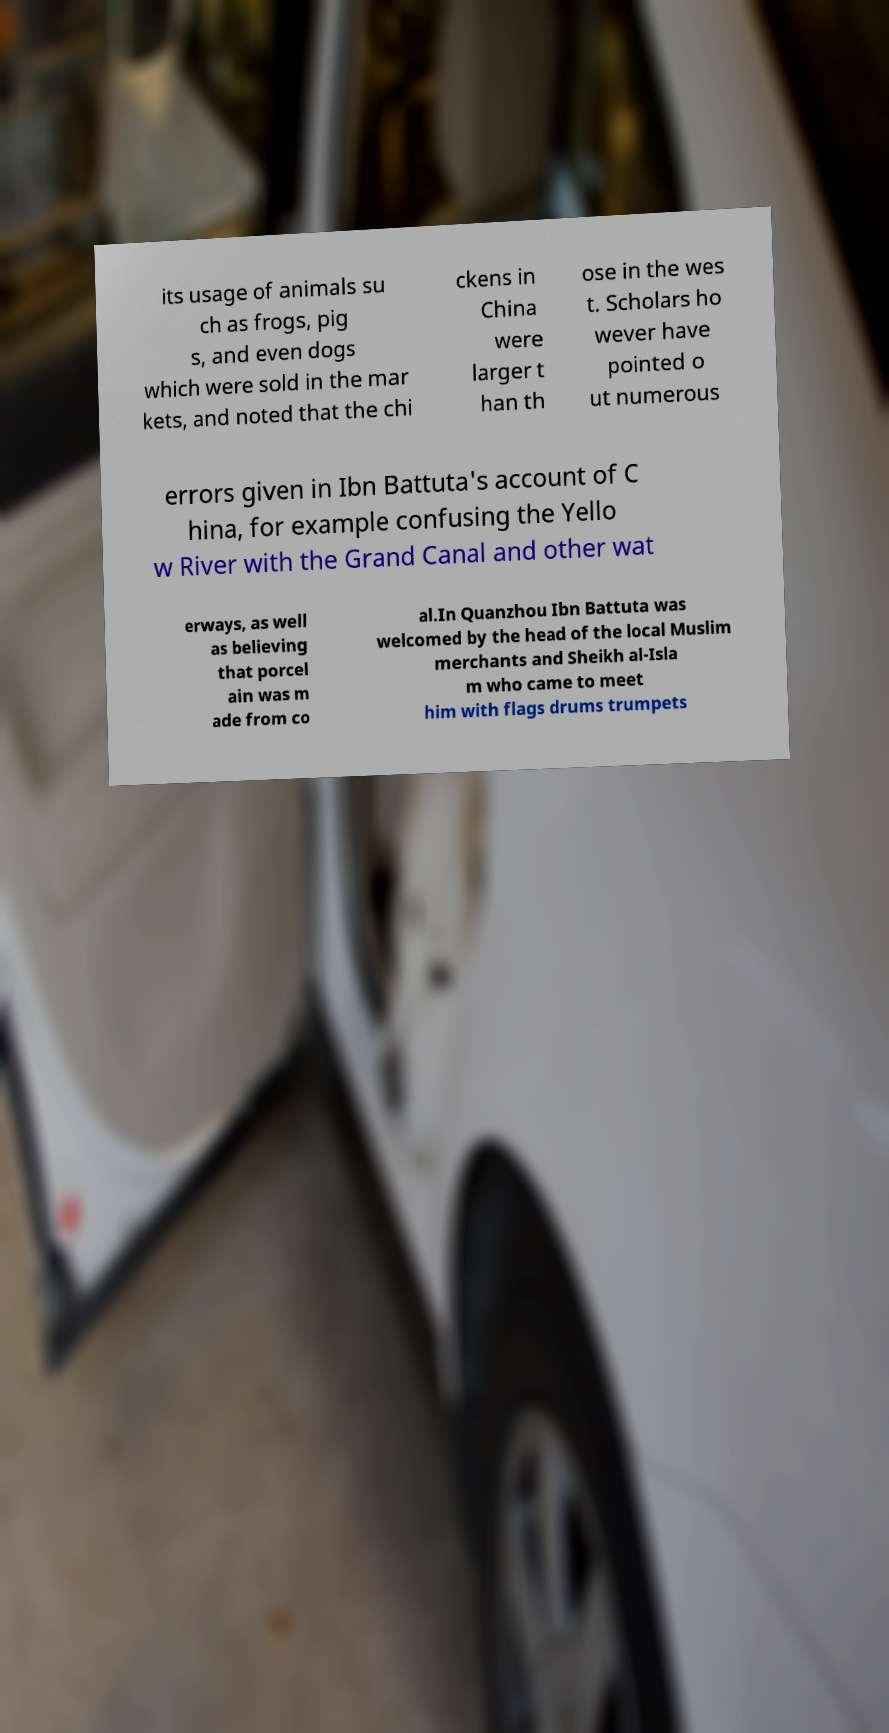Can you accurately transcribe the text from the provided image for me? its usage of animals su ch as frogs, pig s, and even dogs which were sold in the mar kets, and noted that the chi ckens in China were larger t han th ose in the wes t. Scholars ho wever have pointed o ut numerous errors given in Ibn Battuta's account of C hina, for example confusing the Yello w River with the Grand Canal and other wat erways, as well as believing that porcel ain was m ade from co al.In Quanzhou Ibn Battuta was welcomed by the head of the local Muslim merchants and Sheikh al-Isla m who came to meet him with flags drums trumpets 